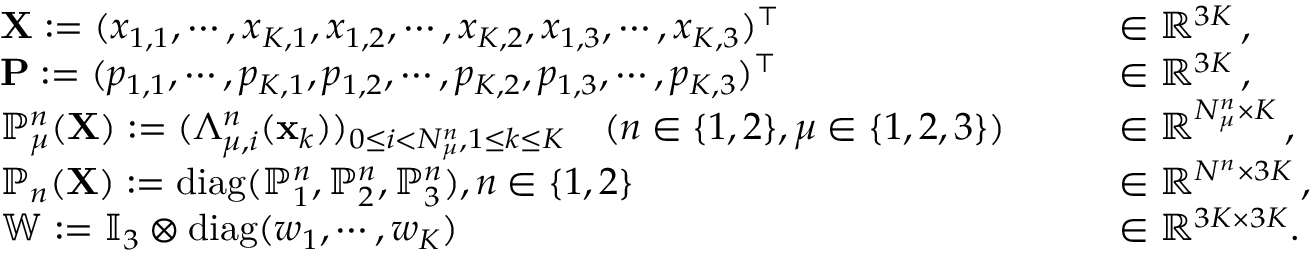<formula> <loc_0><loc_0><loc_500><loc_500>\begin{array} { r l r l } & { { \mathbf X } \colon = ( x _ { 1 , 1 } , \cdots , x _ { K , 1 } , x _ { 1 , 2 } , \cdots , x _ { K , 2 } , x _ { 1 , 3 } , \cdots , x _ { K , 3 } ) ^ { \top } \quad } & & { \in \mathbb { R } ^ { 3 K } \, , } \\ & { { \mathbf P } \colon = ( p _ { 1 , 1 } , \cdots , p _ { K , 1 } , p _ { 1 , 2 } , \cdots , p _ { K , 2 } , p _ { 1 , 3 } , \cdots , p _ { K , 3 } ) ^ { \top } \quad } & & { \in \mathbb { R } ^ { 3 K } \, , } \\ & { \mathbb { P } _ { \mu } ^ { n } ( { \mathbf X } ) \colon = ( \Lambda _ { \mu , i } ^ { n } ( { \mathbf x } _ { k } ) ) _ { 0 \leq i < N _ { \mu } ^ { n } , 1 \leq k \leq K } \quad ( n \in \{ 1 , 2 \} , \mu \in \{ 1 , 2 , 3 \} ) \quad } & & { \in \mathbb { R } ^ { N _ { \mu } ^ { n } \times K } \, , } \\ & { \mathbb { P } _ { n } ( { \mathbf X } ) \colon = d i a g ( \mathbb { P } _ { 1 } ^ { n } , \mathbb { P } _ { 2 } ^ { n } , \mathbb { P } _ { 3 } ^ { n } ) , n \in \{ 1 , 2 \} \quad } & & { \in \mathbb { R } ^ { N ^ { n } \times 3 K } \, , } \\ & { \mathbb { W } \colon = \mathbb { I } _ { 3 } \otimes d i a g ( w _ { 1 } , \cdots , w _ { K } ) \quad } & & { \in \mathbb { R } ^ { 3 K \times 3 K } . } \end{array}</formula> 